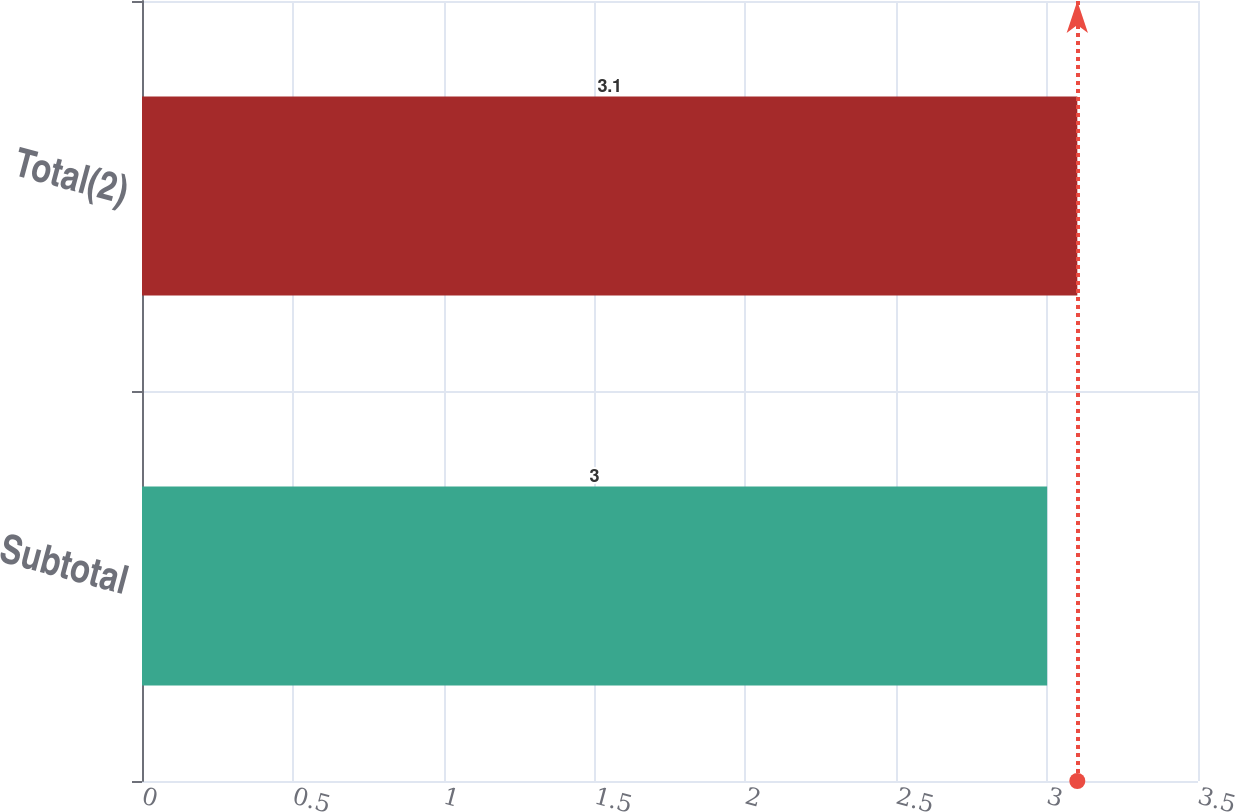Convert chart to OTSL. <chart><loc_0><loc_0><loc_500><loc_500><bar_chart><fcel>Subtotal<fcel>Total(2)<nl><fcel>3<fcel>3.1<nl></chart> 